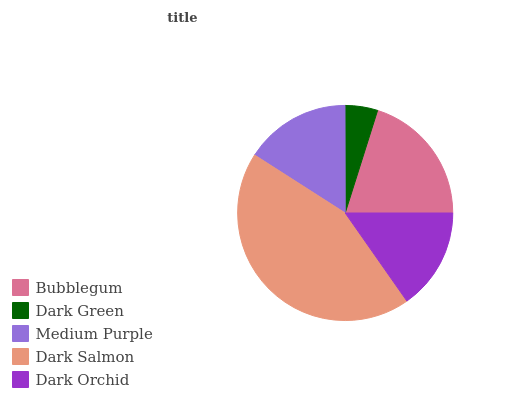Is Dark Green the minimum?
Answer yes or no. Yes. Is Dark Salmon the maximum?
Answer yes or no. Yes. Is Medium Purple the minimum?
Answer yes or no. No. Is Medium Purple the maximum?
Answer yes or no. No. Is Medium Purple greater than Dark Green?
Answer yes or no. Yes. Is Dark Green less than Medium Purple?
Answer yes or no. Yes. Is Dark Green greater than Medium Purple?
Answer yes or no. No. Is Medium Purple less than Dark Green?
Answer yes or no. No. Is Medium Purple the high median?
Answer yes or no. Yes. Is Medium Purple the low median?
Answer yes or no. Yes. Is Dark Orchid the high median?
Answer yes or no. No. Is Dark Green the low median?
Answer yes or no. No. 